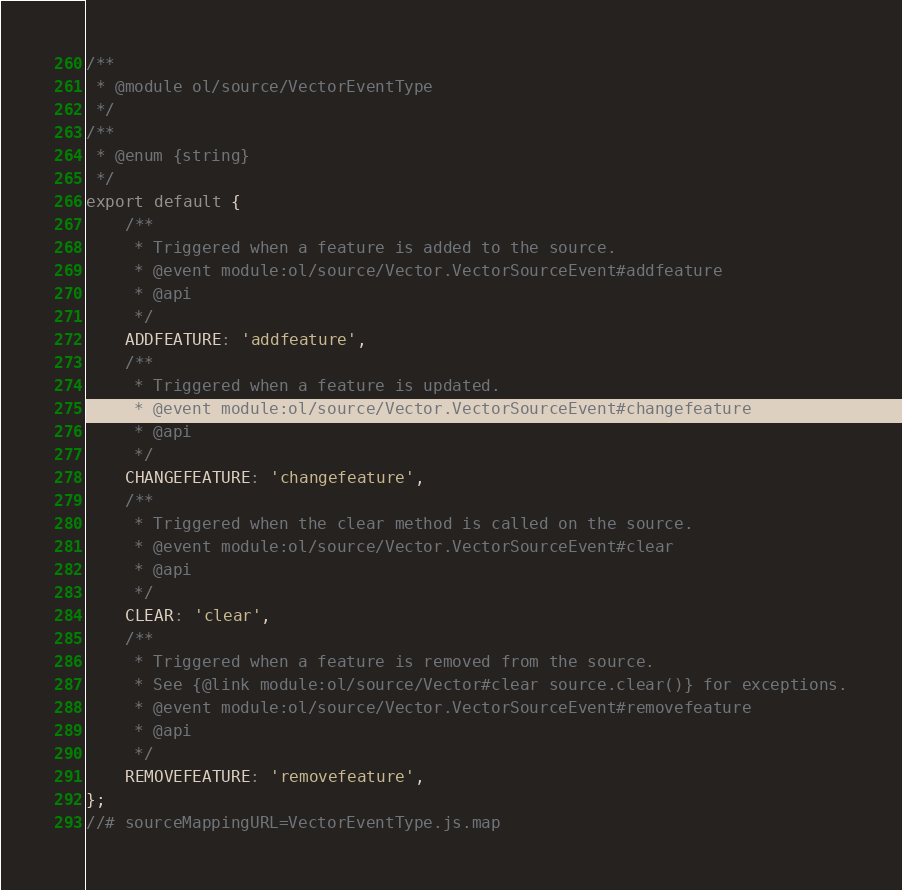<code> <loc_0><loc_0><loc_500><loc_500><_JavaScript_>/**
 * @module ol/source/VectorEventType
 */
/**
 * @enum {string}
 */
export default {
    /**
     * Triggered when a feature is added to the source.
     * @event module:ol/source/Vector.VectorSourceEvent#addfeature
     * @api
     */
    ADDFEATURE: 'addfeature',
    /**
     * Triggered when a feature is updated.
     * @event module:ol/source/Vector.VectorSourceEvent#changefeature
     * @api
     */
    CHANGEFEATURE: 'changefeature',
    /**
     * Triggered when the clear method is called on the source.
     * @event module:ol/source/Vector.VectorSourceEvent#clear
     * @api
     */
    CLEAR: 'clear',
    /**
     * Triggered when a feature is removed from the source.
     * See {@link module:ol/source/Vector#clear source.clear()} for exceptions.
     * @event module:ol/source/Vector.VectorSourceEvent#removefeature
     * @api
     */
    REMOVEFEATURE: 'removefeature',
};
//# sourceMappingURL=VectorEventType.js.map</code> 